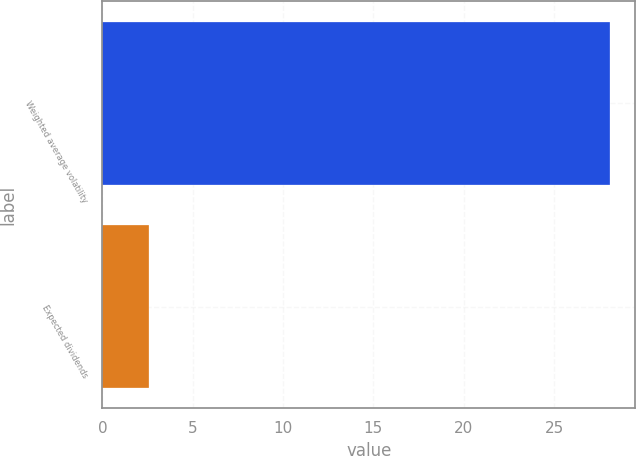Convert chart. <chart><loc_0><loc_0><loc_500><loc_500><bar_chart><fcel>Weighted average volatility<fcel>Expected dividends<nl><fcel>28.1<fcel>2.6<nl></chart> 